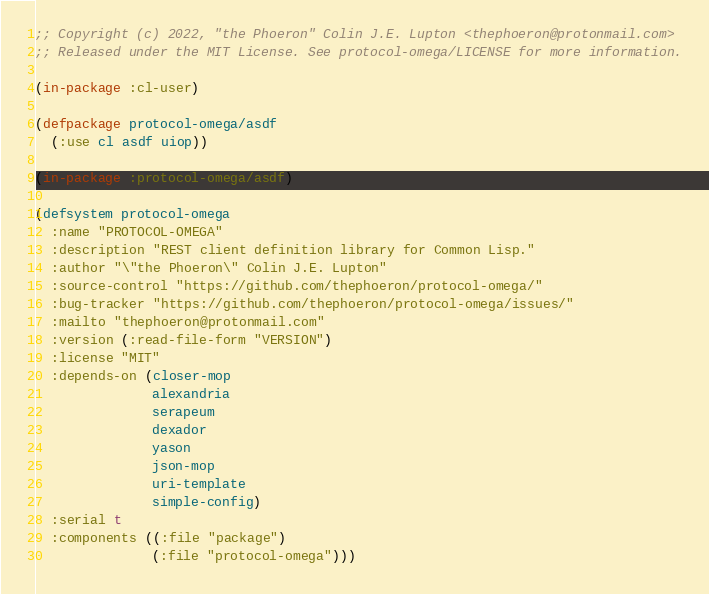<code> <loc_0><loc_0><loc_500><loc_500><_Lisp_>;; Copyright (c) 2022, "the Phoeron" Colin J.E. Lupton <thephoeron@protonmail.com>
;; Released under the MIT License. See protocol-omega/LICENSE for more information.

(in-package :cl-user)

(defpackage protocol-omega/asdf
  (:use cl asdf uiop))

(in-package :protocol-omega/asdf)

(defsystem protocol-omega
  :name "PROTOCOL-OMEGA"
  :description "REST client definition library for Common Lisp."
  :author "\"the Phoeron\" Colin J.E. Lupton"
  :source-control "https://github.com/thephoeron/protocol-omega/"
  :bug-tracker "https://github.com/thephoeron/protocol-omega/issues/"
  :mailto "thephoeron@protonmail.com"
  :version (:read-file-form "VERSION")
  :license "MIT"
  :depends-on (closer-mop
               alexandria
               serapeum
               dexador
               yason
               json-mop
               uri-template
               simple-config)
  :serial t
  :components ((:file "package")
               (:file "protocol-omega")))
</code> 